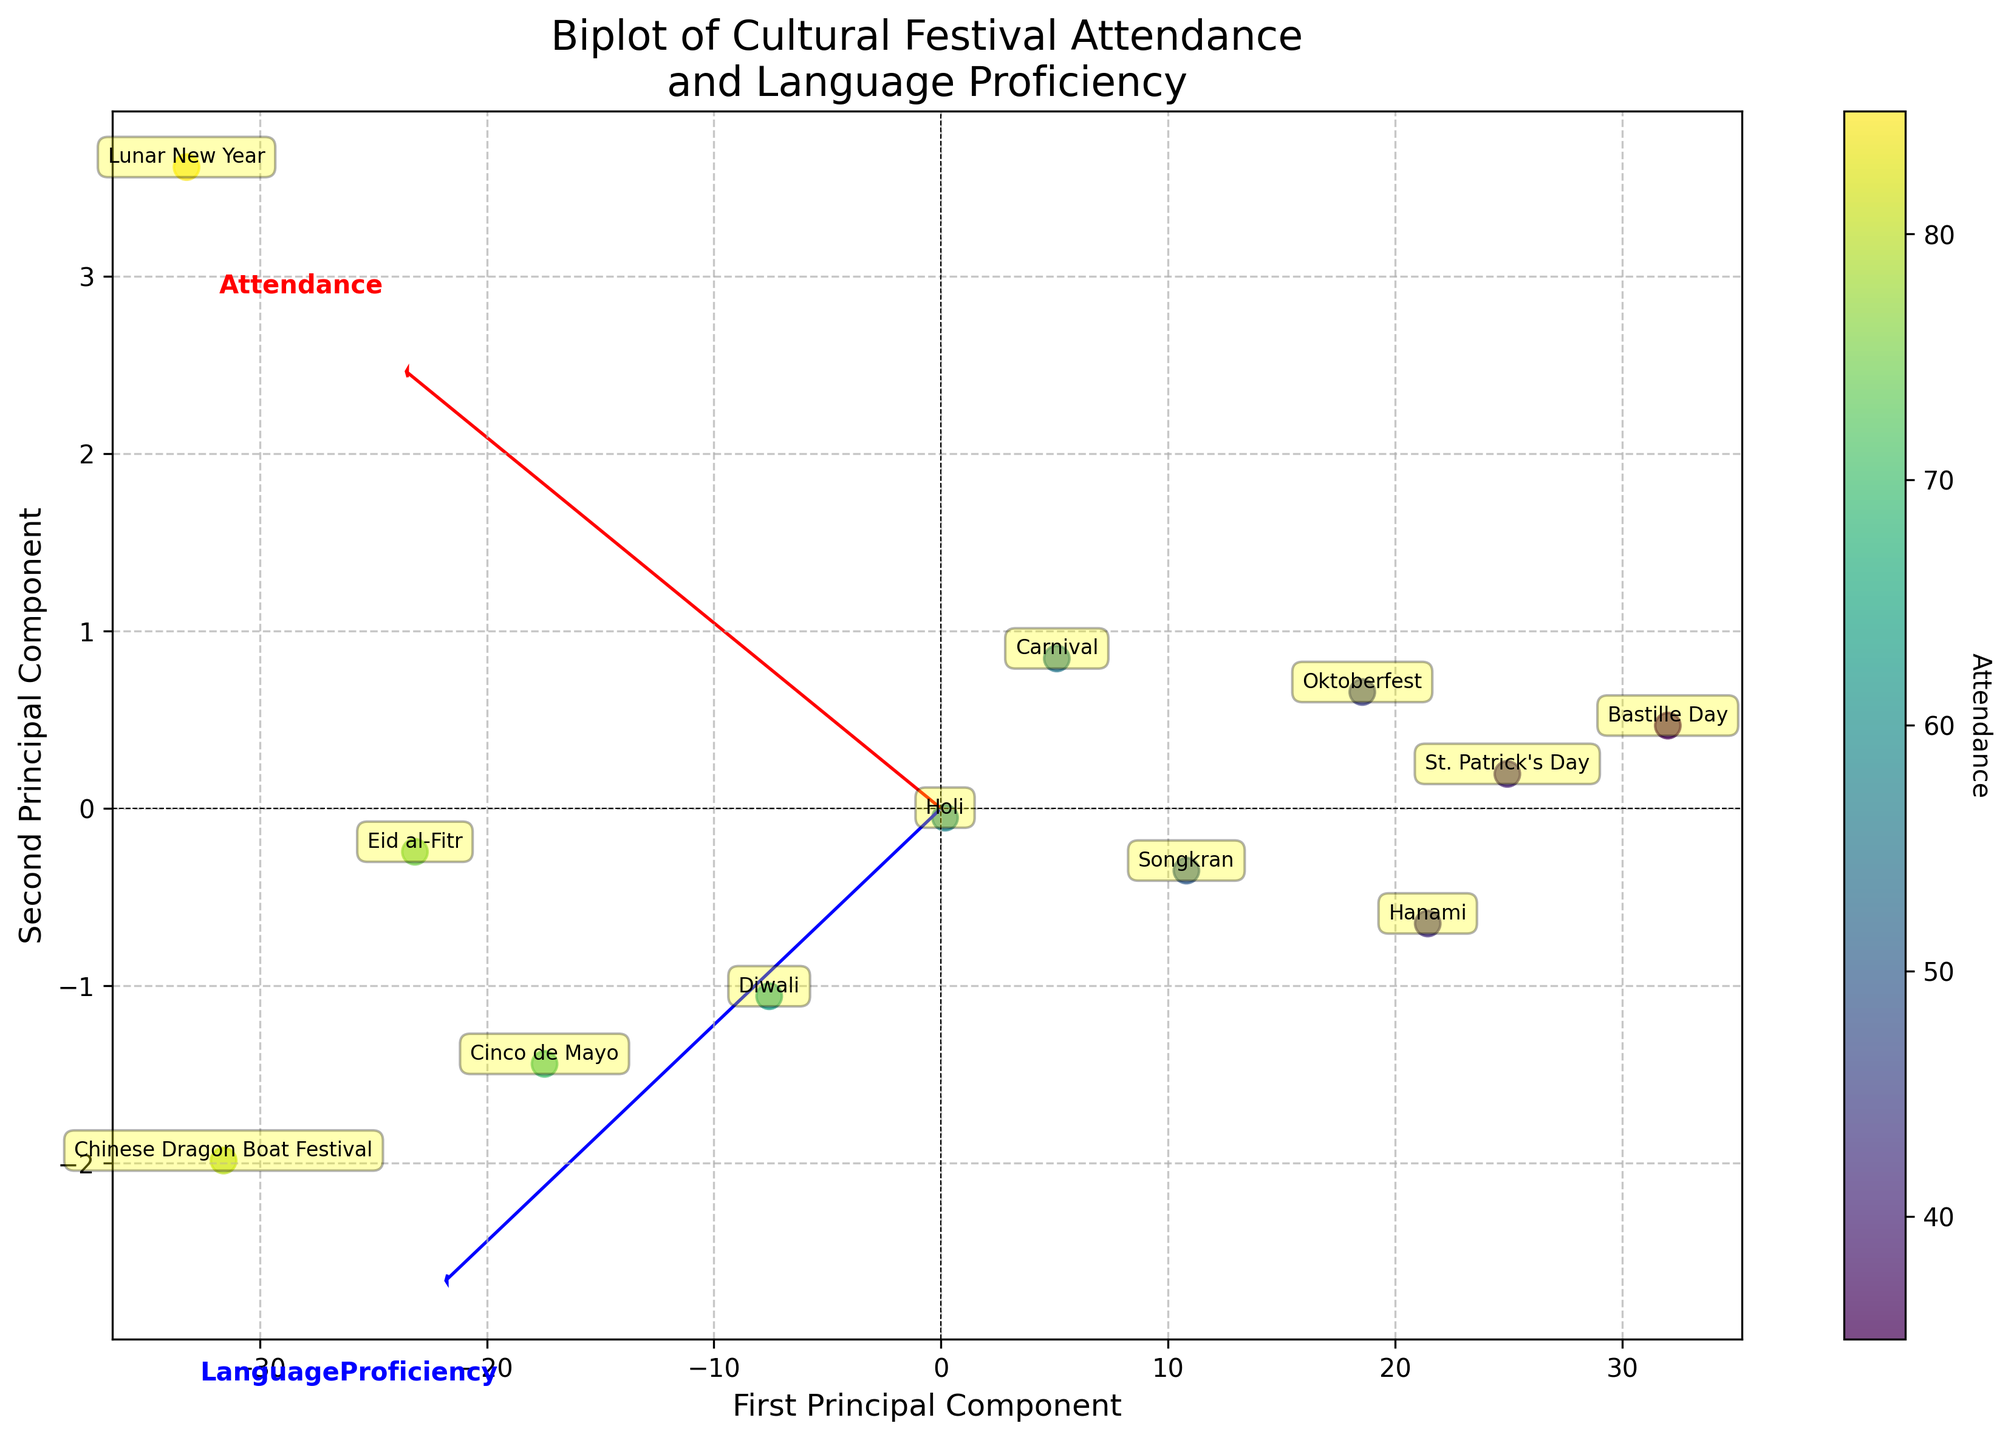How many festivals are plotted in the figure? To answer this, count the labels in the biplot. Each festival has a label associated with a data point.
Answer: 12 What festival has the highest value on the first principal component? Looking at the biplot, observe where the data points are positioned along the first principal component axis (x-axis). The point furthest to the right corresponds to the highest value.
Answer: Lunar New Year Which festival has the lowest language proficiency? Based on the visualization, to determine which festival corresponds to the lowest value along the language proficiency vector, look at the projection of each festival's data point on the blue vector.
Answer: Bastille Day How do the attendance and language proficiency compare for Eid al-Fitr and Holi? To compare these festivals, locate them on the biplot and observe their respective positions on the two axes. Eid al-Fitr is higher on both vectors (attendance and language proficiency) compared to Holi.
Answer: Eid al-Fitr is higher for both aspects What is the relationship between the vectors for 'Attendance' and 'Language Proficiency'? Examine the directions and lengths of both vectors. The vectors are pointing in somewhat similar directions, indicating a positive relationship where, generally, higher attendance is associated with higher language proficiency.
Answer: Positive relationship Which festival has the closest value in terms of 'Attendance' to the St. Patrick's Day? Find the position of St. Patrick's Day and see which other festival is nearest along the direction of the attendance vector.
Answer: Hanami Of the festivals plotted, which ones fall almost directly on the x-axis? Identify which festivals have data points closest to the x-axis (or first principal component) with minimal deviation on the y-axis. These points indicate a significant principal component 1 contribution but minimal principal component 2 deviation.
Answer: St. Patrick's Day What cultural festival is positioned closest to the origin? Locate the data point nearest to the (0,0) coordinates in the biplot. This represents a festival with low values on the principal components.
Answer: Bastille Day Which festival has a higher value in 'Language Proficiency' but lower in 'Attendance' compared to Songkran? Look for the festival data point that is higher along the language proficiency axis (blue vector) but lower along the attendance axis (red vector) than Songkran.
Answer: Hanami 